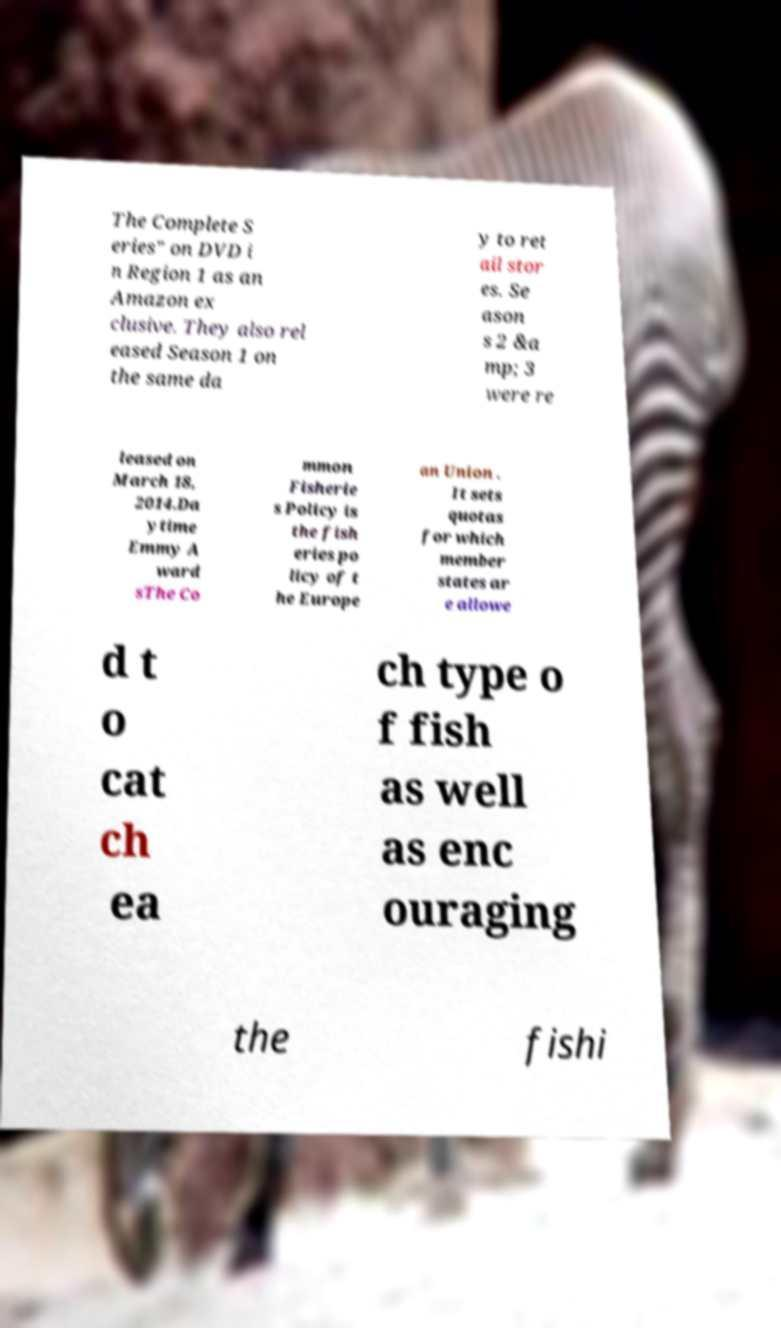Can you read and provide the text displayed in the image?This photo seems to have some interesting text. Can you extract and type it out for me? The Complete S eries" on DVD i n Region 1 as an Amazon ex clusive. They also rel eased Season 1 on the same da y to ret ail stor es. Se ason s 2 &a mp; 3 were re leased on March 18, 2014.Da ytime Emmy A ward sThe Co mmon Fisherie s Policy is the fish eries po licy of t he Europe an Union . It sets quotas for which member states ar e allowe d t o cat ch ea ch type o f fish as well as enc ouraging the fishi 